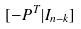<formula> <loc_0><loc_0><loc_500><loc_500>[ - P ^ { T } | I _ { n - k } ]</formula> 